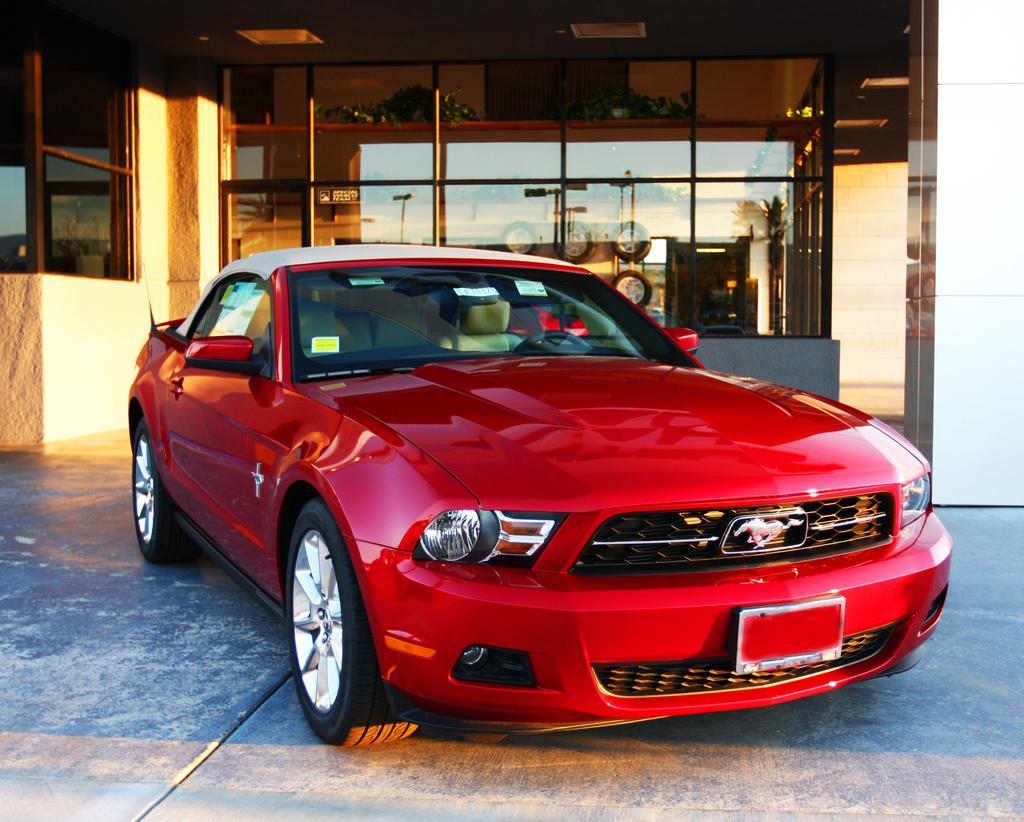Could you give a brief overview of what you see in this image? Here we can see a red vehicle. Background there are glass windows. Through this glass windows we can see wheels. On this glass windows there is a reflection of light poles. 